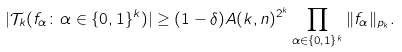<formula> <loc_0><loc_0><loc_500><loc_500>| \mathcal { T } _ { k } ( f _ { \alpha } \colon \alpha \in \{ 0 , 1 \} ^ { k } ) | \geq ( 1 - \delta ) A ( k , n ) ^ { 2 ^ { k } } \prod _ { \alpha \in \{ 0 , 1 \} ^ { k } } \| f _ { \alpha } \| _ { p _ { k } } .</formula> 